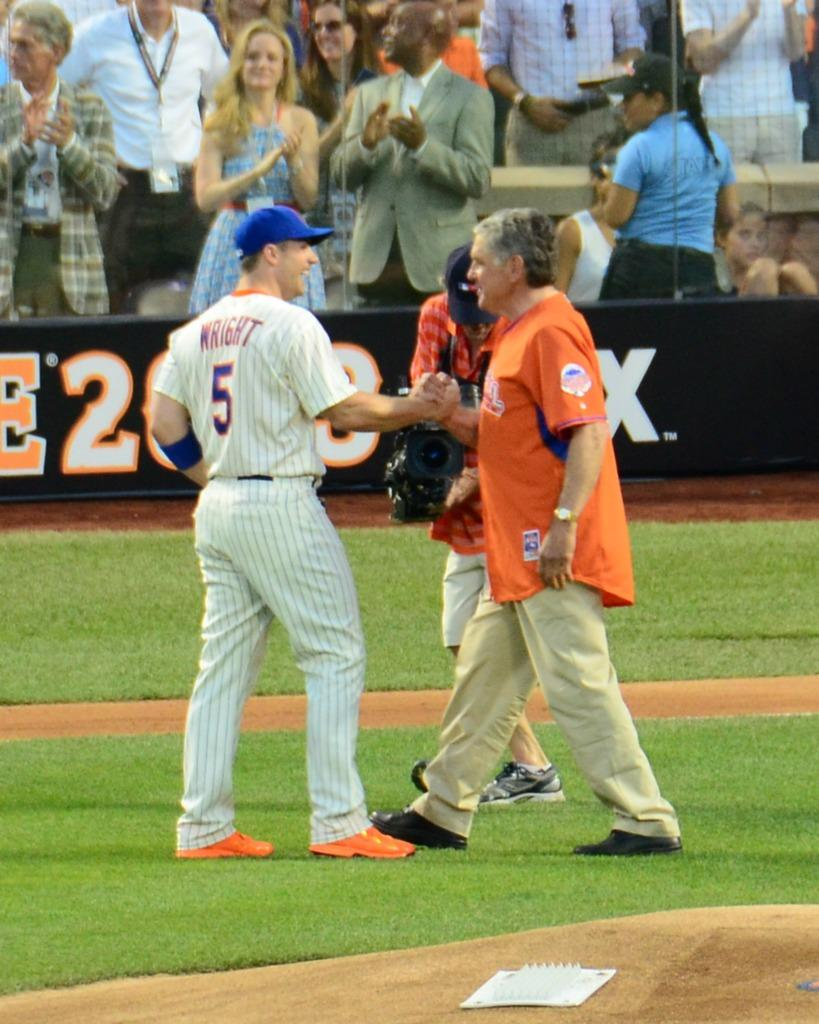<image>
Describe the image concisely. A baseball game is going on with fans watching and the player WRIGHT #5 grasping the hand of another man in the field. 